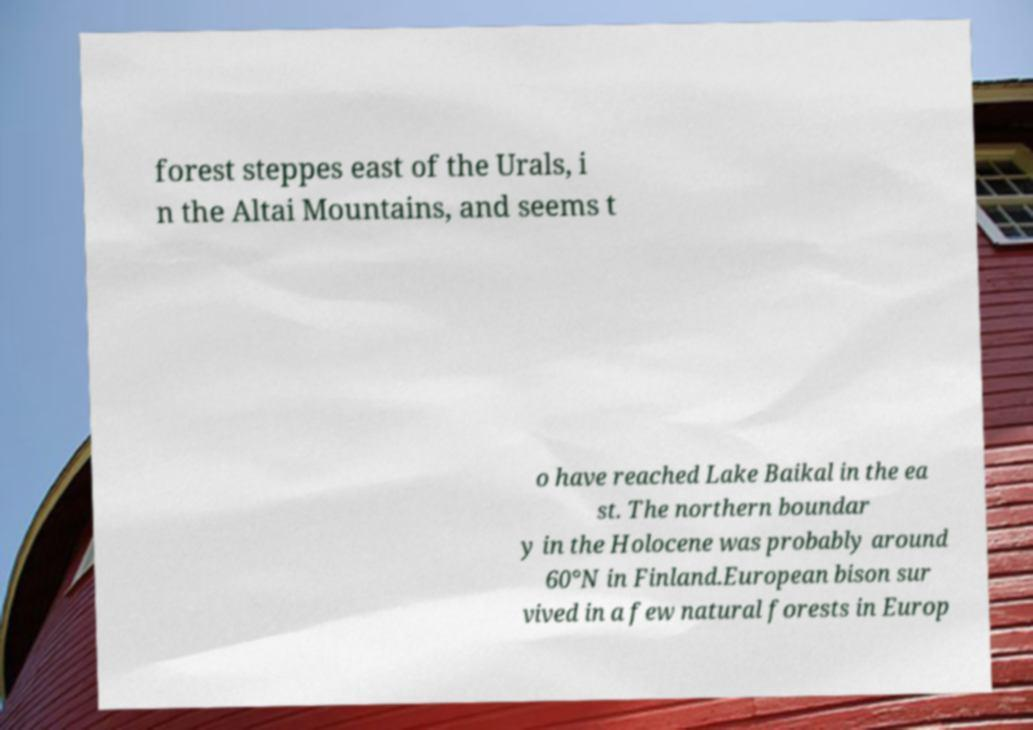I need the written content from this picture converted into text. Can you do that? forest steppes east of the Urals, i n the Altai Mountains, and seems t o have reached Lake Baikal in the ea st. The northern boundar y in the Holocene was probably around 60°N in Finland.European bison sur vived in a few natural forests in Europ 